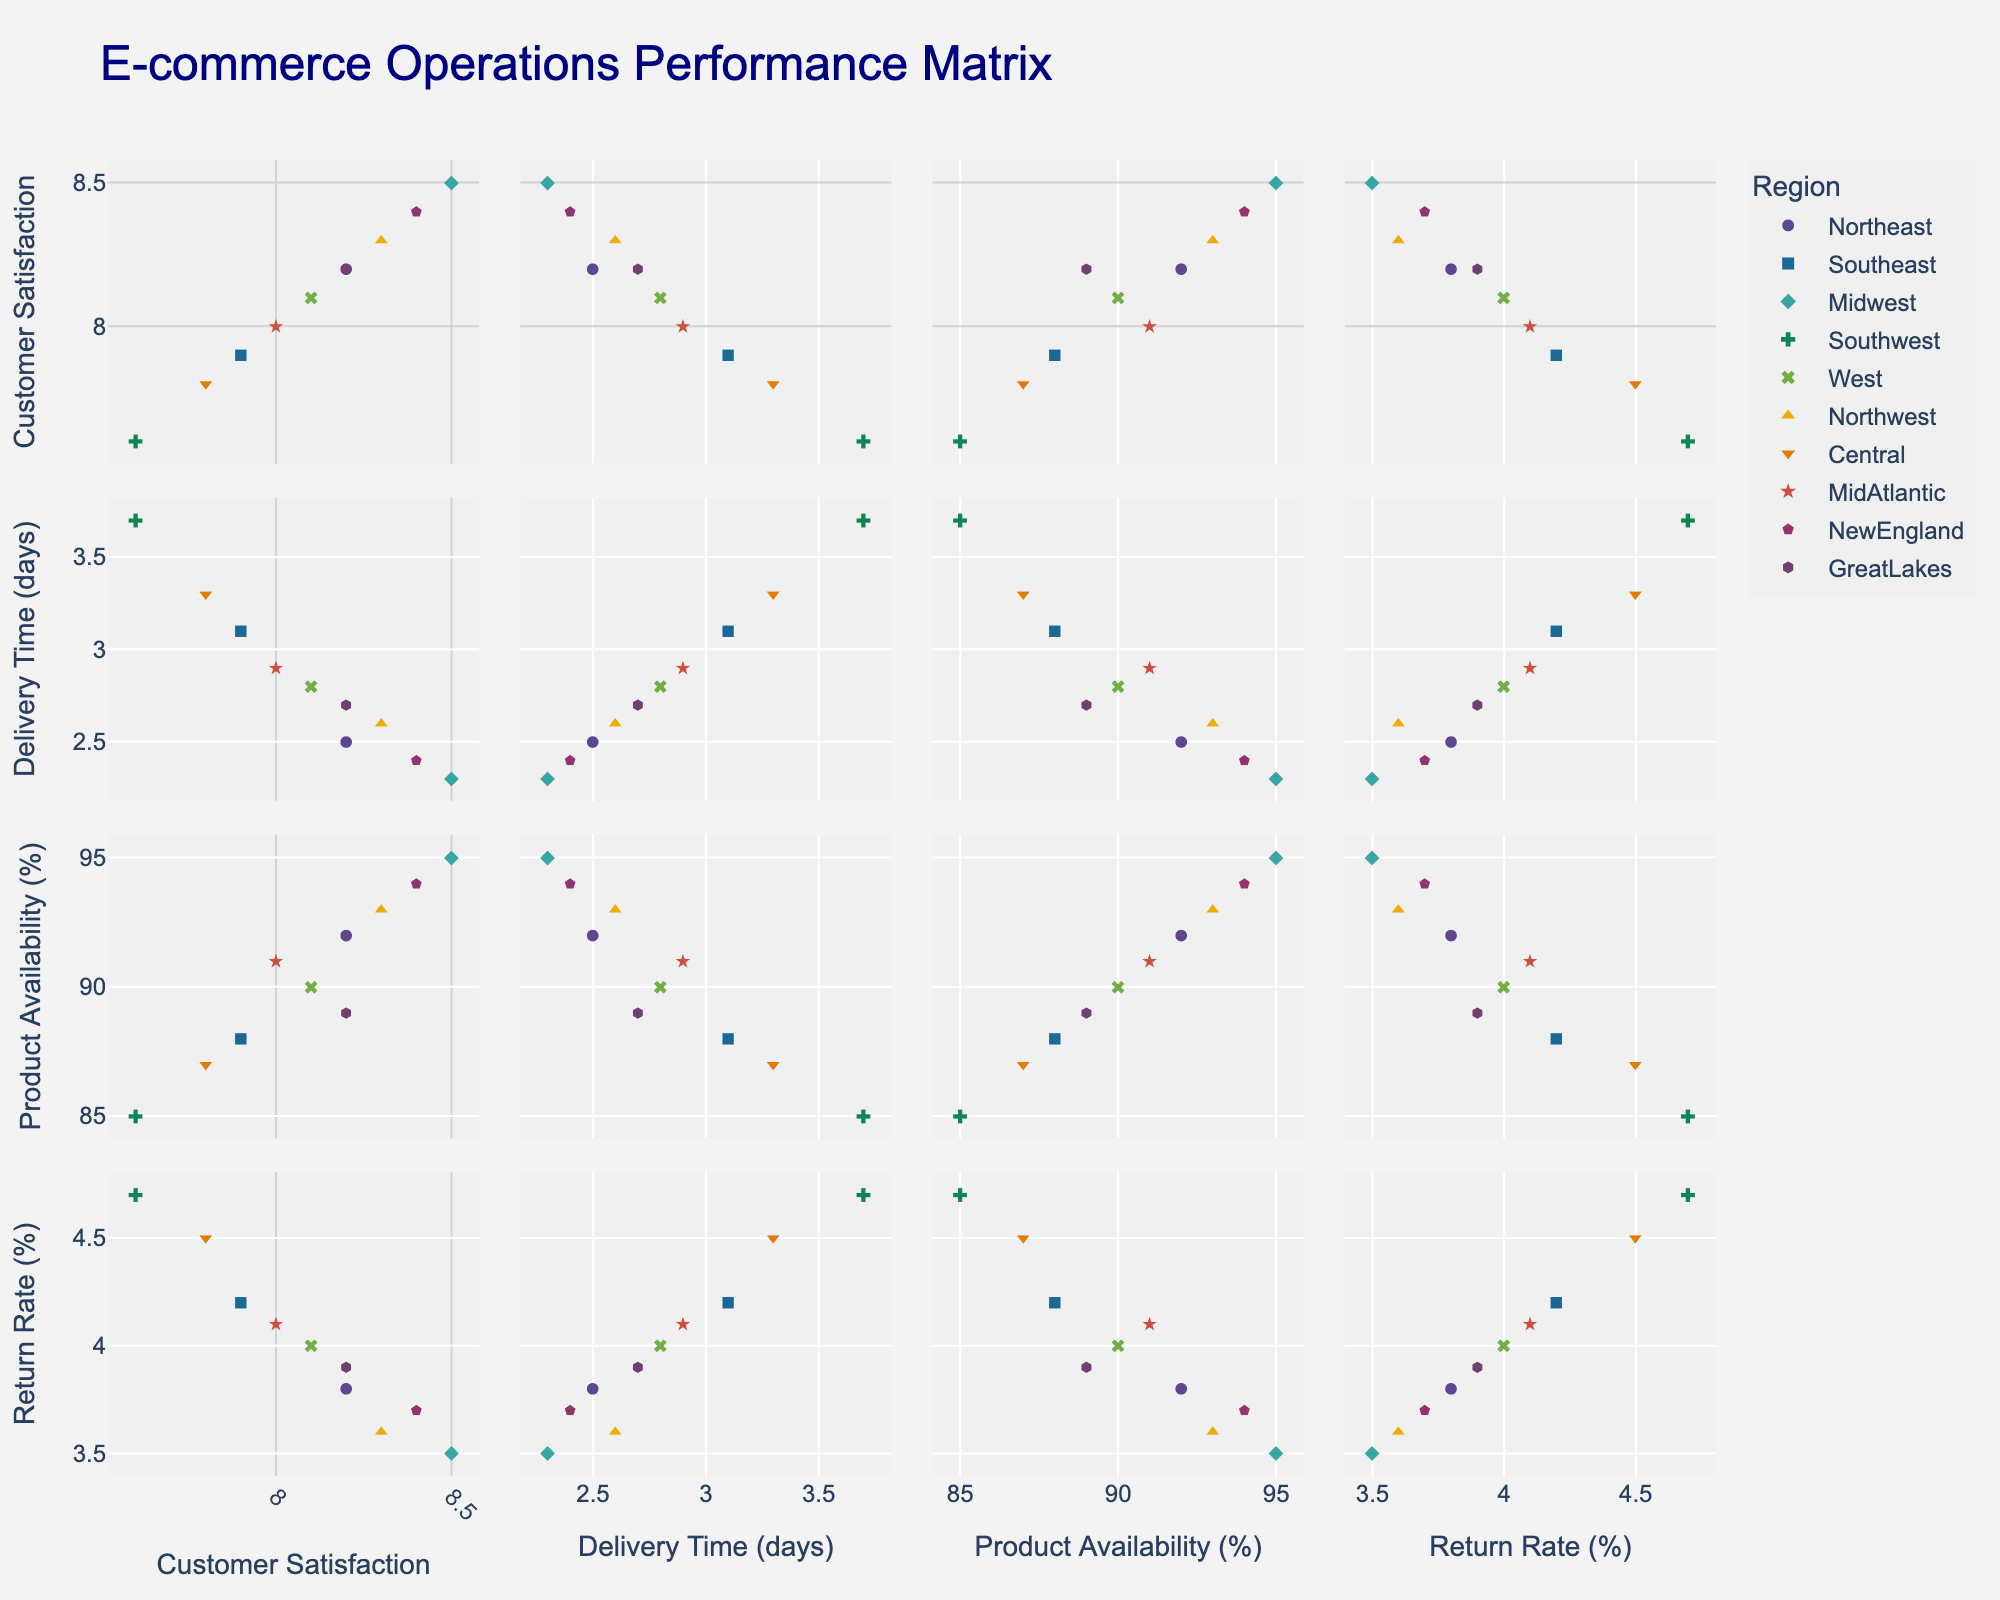What is the average salary for Software Developers in the Technology industry? The figure depicts the average salary of entry-level positions in various industries. Looking at the bubble that represents the Technology industry, we see the average salary for Software Developers.
Answer: $75,000 Which industry has the highest job growth rate? By examining the bubbles plotted on the 'Salary vs Job Growth Rate' chart, the bubble representing the highest job growth rate stands out. The Technology industry's bubble is at the highest position on the x-axis.
Answer: Technology What is the relationship between the number of openings and average salary for Registered Nurses? Referring to the 'Salary vs Openings' chart, find the bubble for the Healthcare industry. Notice the horizontal (x-axis for openings) and vertical (y-axis for average salary) positions of this bubble.
Answer: 4500 openings and $60,000 salary Compare the job growth rate of Financial Analysts and Digital Marketing Specialists. Look for the Finance and Marketing bubbles in the 'Salary vs Job Growth Rate' chart and note their x-axis positions. The Financial Analysts' bubble is at 7%, and the Digital Marketing Specialists' bubble is at 8%.
Answer: Digital Marketing Specialists have a higher growth rate Which industry has the most job openings? The 'Industry Overview' pie chart indicates which industry has the largest portion. The Technology section appears largest, representing the most openings.
Answer: Technology How does the average salary for Store Managers compare to Project Coordinators? In the 'Salary vs Job Growth Rate' chart, noting the y-axis positions of the Retail and Construction industry bubbles, Store Managers have a lower average salary compared to Project Coordinators.
Answer: Store Managers: $40,000, Project Coordinators: $48,000 Identify the industry with the lowest average salary and its corresponding value. On the 'Salary vs Job Growth Rate' chart, the lowest bubble on the y-axis indicates the industry with the lowest average salary. The Hospitality industry's bubble is at the bottom.
Answer: Hospitality, $35,000 Which entry-level position has the highest number of job openings, and how does its job growth rate compare to Production Supervisors? The 'Industry Overview' pie chart shows Software Developers in Technology have the most openings. Comparing this position's growth rate on the 'Salary vs Job Growth Rate' chart with Production Supervisors, Software Developers have a higher growth rate (12% vs 3%).
Answer: Software Developers, higher growth rate 